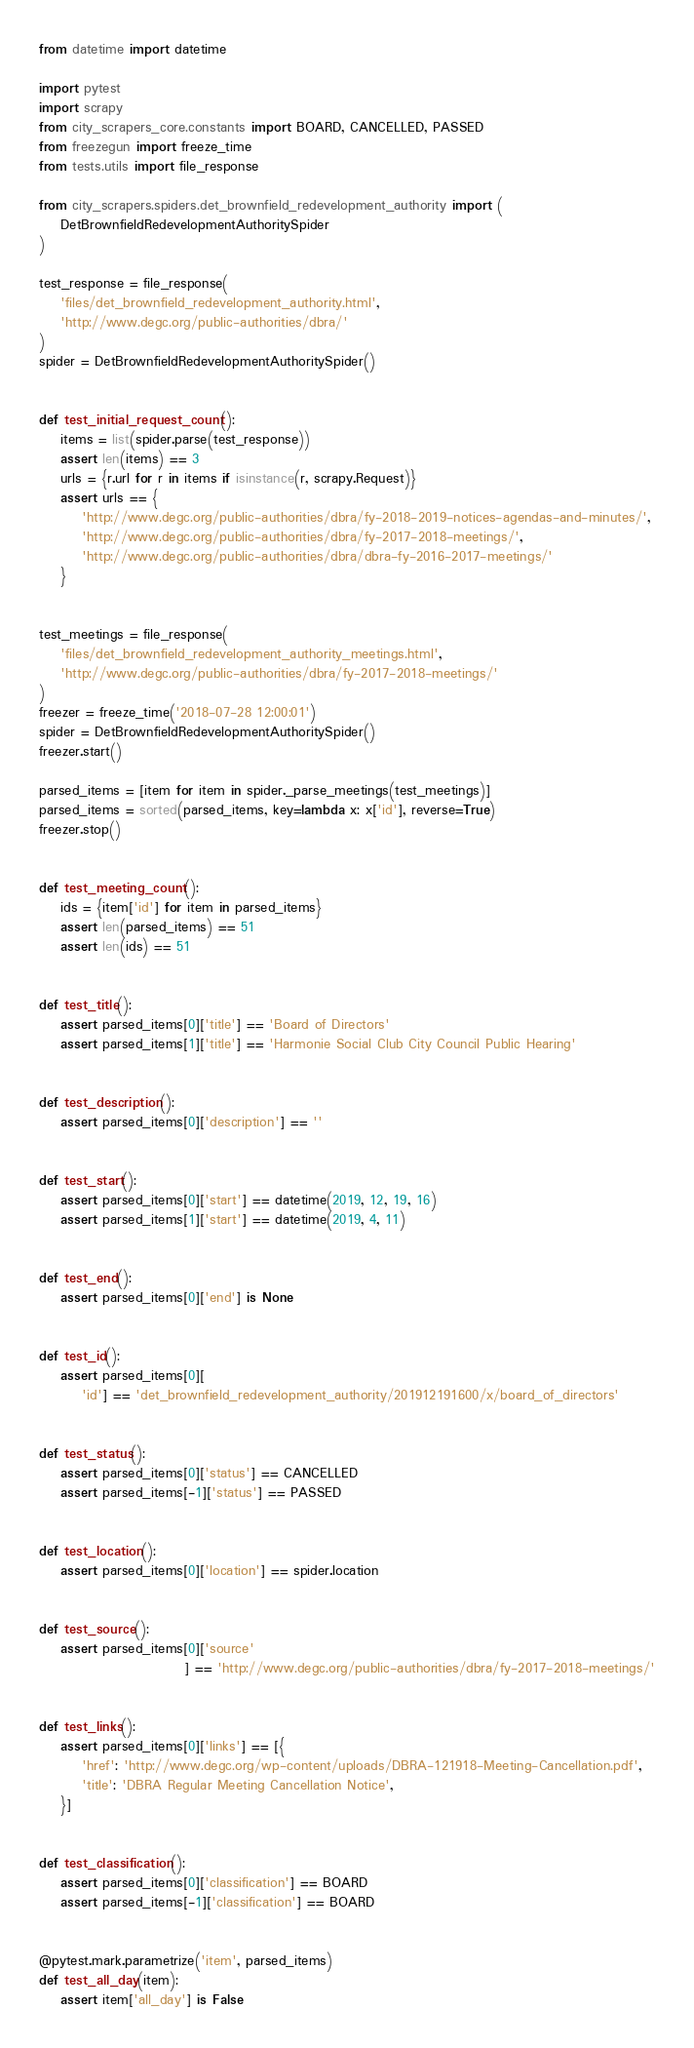Convert code to text. <code><loc_0><loc_0><loc_500><loc_500><_Python_>from datetime import datetime

import pytest
import scrapy
from city_scrapers_core.constants import BOARD, CANCELLED, PASSED
from freezegun import freeze_time
from tests.utils import file_response

from city_scrapers.spiders.det_brownfield_redevelopment_authority import (
    DetBrownfieldRedevelopmentAuthoritySpider
)

test_response = file_response(
    'files/det_brownfield_redevelopment_authority.html',
    'http://www.degc.org/public-authorities/dbra/'
)
spider = DetBrownfieldRedevelopmentAuthoritySpider()


def test_initial_request_count():
    items = list(spider.parse(test_response))
    assert len(items) == 3
    urls = {r.url for r in items if isinstance(r, scrapy.Request)}
    assert urls == {
        'http://www.degc.org/public-authorities/dbra/fy-2018-2019-notices-agendas-and-minutes/',
        'http://www.degc.org/public-authorities/dbra/fy-2017-2018-meetings/',
        'http://www.degc.org/public-authorities/dbra/dbra-fy-2016-2017-meetings/'
    }


test_meetings = file_response(
    'files/det_brownfield_redevelopment_authority_meetings.html',
    'http://www.degc.org/public-authorities/dbra/fy-2017-2018-meetings/'
)
freezer = freeze_time('2018-07-28 12:00:01')
spider = DetBrownfieldRedevelopmentAuthoritySpider()
freezer.start()

parsed_items = [item for item in spider._parse_meetings(test_meetings)]
parsed_items = sorted(parsed_items, key=lambda x: x['id'], reverse=True)
freezer.stop()


def test_meeting_count():
    ids = {item['id'] for item in parsed_items}
    assert len(parsed_items) == 51
    assert len(ids) == 51


def test_title():
    assert parsed_items[0]['title'] == 'Board of Directors'
    assert parsed_items[1]['title'] == 'Harmonie Social Club City Council Public Hearing'


def test_description():
    assert parsed_items[0]['description'] == ''


def test_start():
    assert parsed_items[0]['start'] == datetime(2019, 12, 19, 16)
    assert parsed_items[1]['start'] == datetime(2019, 4, 11)


def test_end():
    assert parsed_items[0]['end'] is None


def test_id():
    assert parsed_items[0][
        'id'] == 'det_brownfield_redevelopment_authority/201912191600/x/board_of_directors'


def test_status():
    assert parsed_items[0]['status'] == CANCELLED
    assert parsed_items[-1]['status'] == PASSED


def test_location():
    assert parsed_items[0]['location'] == spider.location


def test_source():
    assert parsed_items[0]['source'
                           ] == 'http://www.degc.org/public-authorities/dbra/fy-2017-2018-meetings/'


def test_links():
    assert parsed_items[0]['links'] == [{
        'href': 'http://www.degc.org/wp-content/uploads/DBRA-121918-Meeting-Cancellation.pdf',
        'title': 'DBRA Regular Meeting Cancellation Notice',
    }]


def test_classification():
    assert parsed_items[0]['classification'] == BOARD
    assert parsed_items[-1]['classification'] == BOARD


@pytest.mark.parametrize('item', parsed_items)
def test_all_day(item):
    assert item['all_day'] is False
</code> 